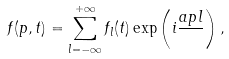<formula> <loc_0><loc_0><loc_500><loc_500>f ( p , t ) = \sum _ { l = - \infty } ^ { + \infty } f _ { l } ( t ) \exp \left ( i \frac { a p l } { } \right ) ,</formula> 